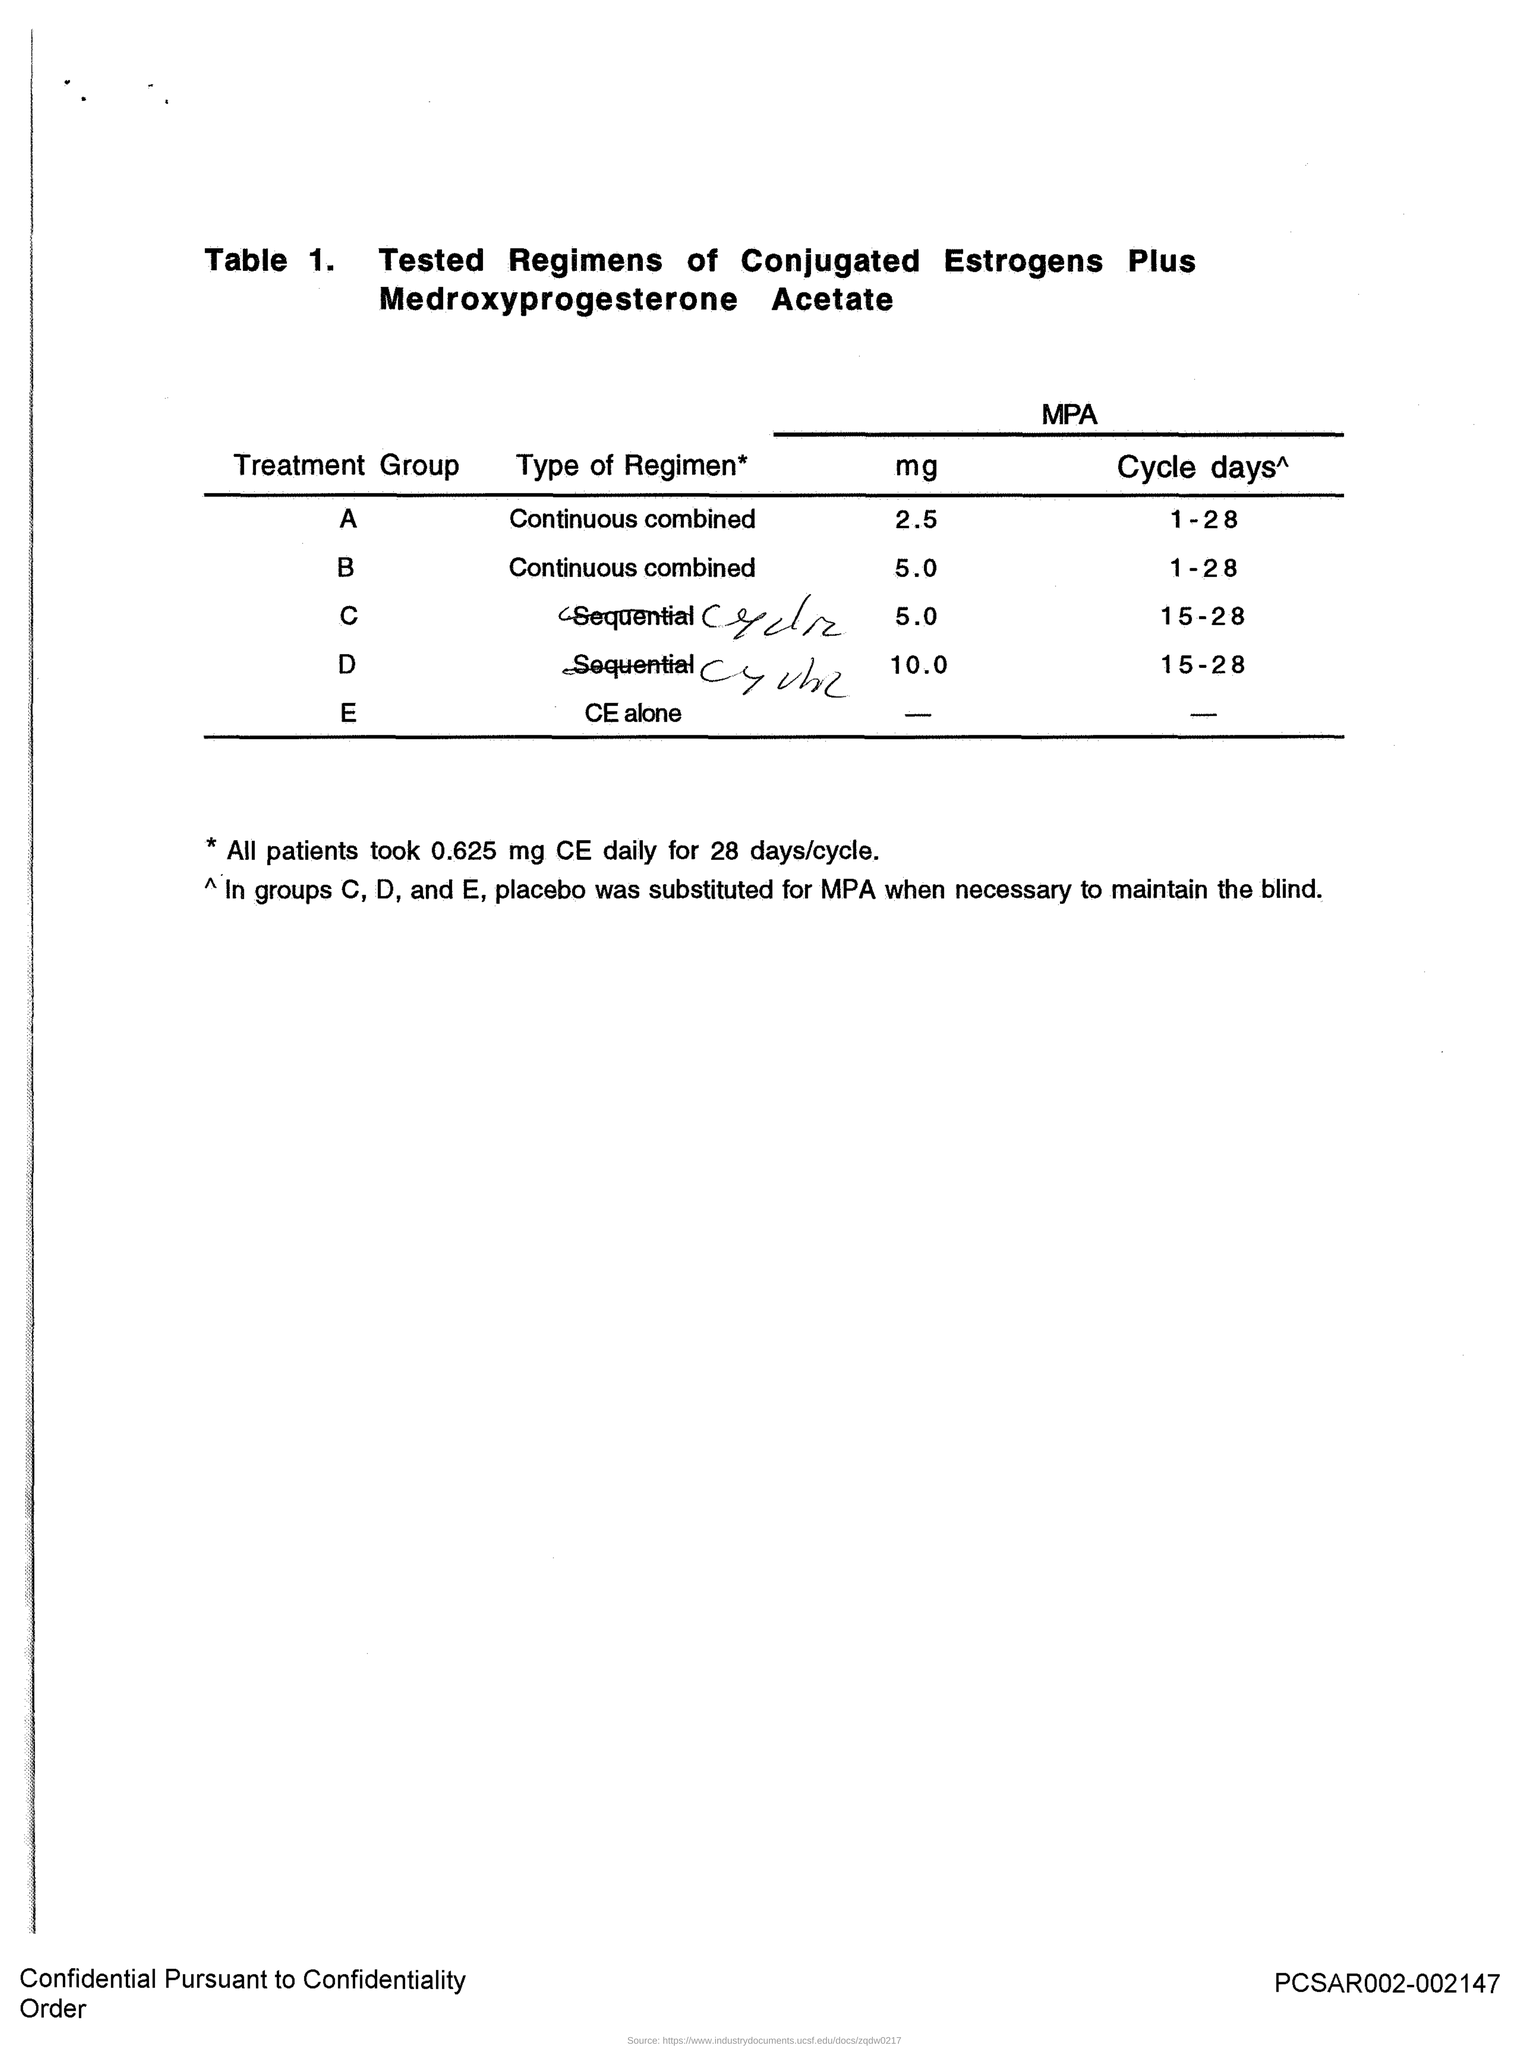What is the title of Table 1?
Give a very brief answer. Tested Regimens of Conjugated Estrogens Plus Medroxyprogesterone Acetate. What is the daily dose taken by all patients for 28days/cycle?
Your answer should be compact. 0.625 mg CE. 